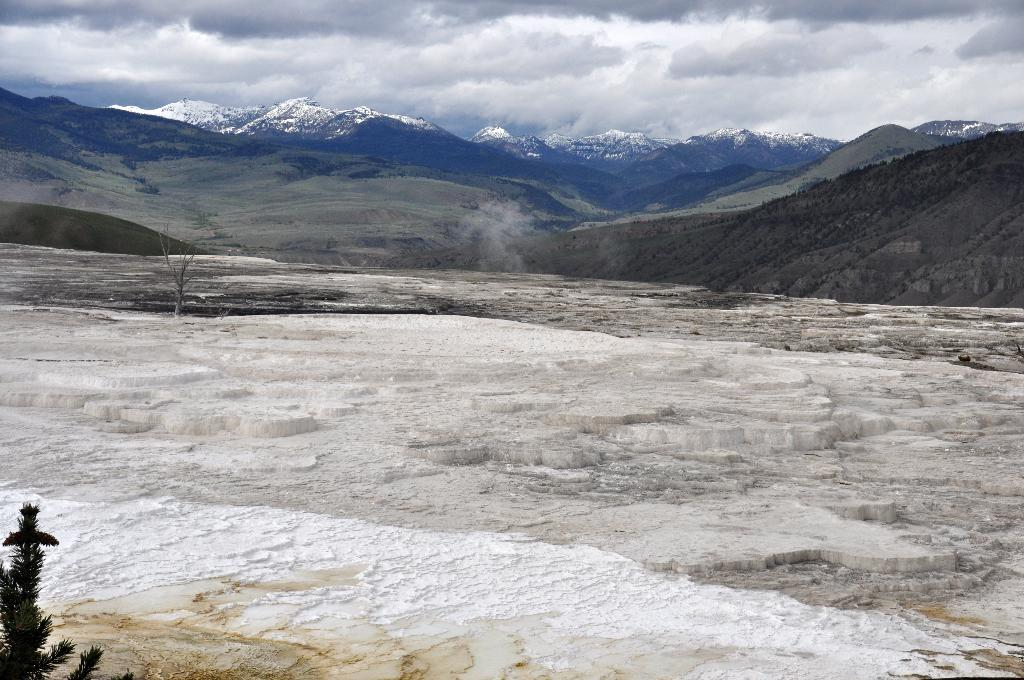What type of natural vegetation is present in the image? There are trees in the image. What type of geological formation can be seen in the image? There are mountains in the image. What part of the natural environment is visible in the image? The sky is visible in the background of the image. What type of wealth is depicted in the image? There is no depiction of wealth in the image; it features trees, mountains, and the sky. How does the image change over time? The image itself does not change over time, as it is a static representation. 